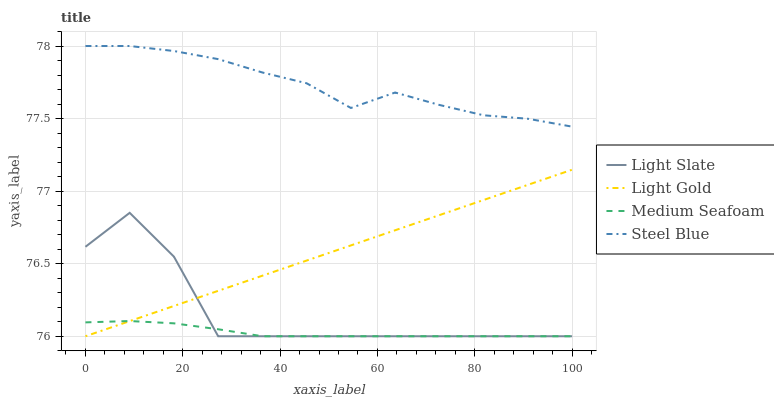Does Medium Seafoam have the minimum area under the curve?
Answer yes or no. Yes. Does Steel Blue have the maximum area under the curve?
Answer yes or no. Yes. Does Light Gold have the minimum area under the curve?
Answer yes or no. No. Does Light Gold have the maximum area under the curve?
Answer yes or no. No. Is Light Gold the smoothest?
Answer yes or no. Yes. Is Light Slate the roughest?
Answer yes or no. Yes. Is Medium Seafoam the smoothest?
Answer yes or no. No. Is Medium Seafoam the roughest?
Answer yes or no. No. Does Light Slate have the lowest value?
Answer yes or no. Yes. Does Steel Blue have the lowest value?
Answer yes or no. No. Does Steel Blue have the highest value?
Answer yes or no. Yes. Does Light Gold have the highest value?
Answer yes or no. No. Is Light Slate less than Steel Blue?
Answer yes or no. Yes. Is Steel Blue greater than Light Gold?
Answer yes or no. Yes. Does Medium Seafoam intersect Light Slate?
Answer yes or no. Yes. Is Medium Seafoam less than Light Slate?
Answer yes or no. No. Is Medium Seafoam greater than Light Slate?
Answer yes or no. No. Does Light Slate intersect Steel Blue?
Answer yes or no. No. 